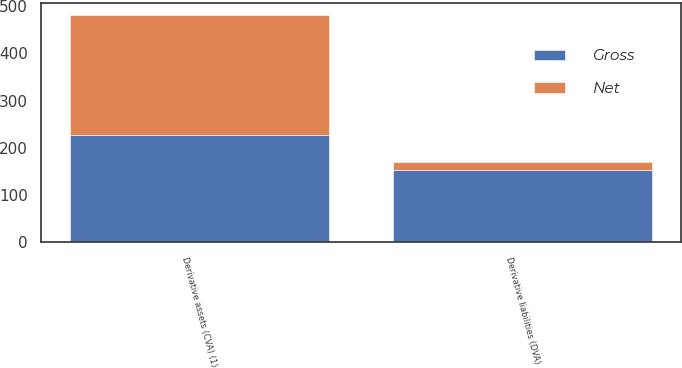<chart> <loc_0><loc_0><loc_500><loc_500><stacked_bar_chart><ecel><fcel>Derivative assets (CVA) (1)<fcel>Derivative liabilities (DVA)<nl><fcel>Net<fcel>255<fcel>18<nl><fcel>Gross<fcel>227<fcel>153<nl></chart> 